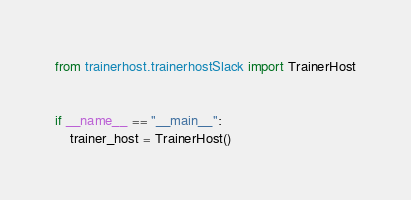<code> <loc_0><loc_0><loc_500><loc_500><_Python_>from trainerhost.trainerhostSlack import TrainerHost


if __name__ == "__main__":
    trainer_host = TrainerHost()
</code> 